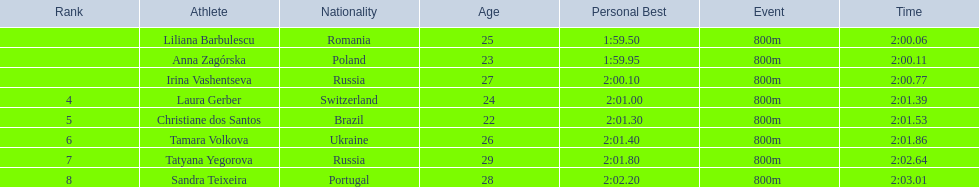Who came in second place at the athletics at the 2003 summer universiade - women's 800 metres? Anna Zagórska. What was her time? 2:00.11. 